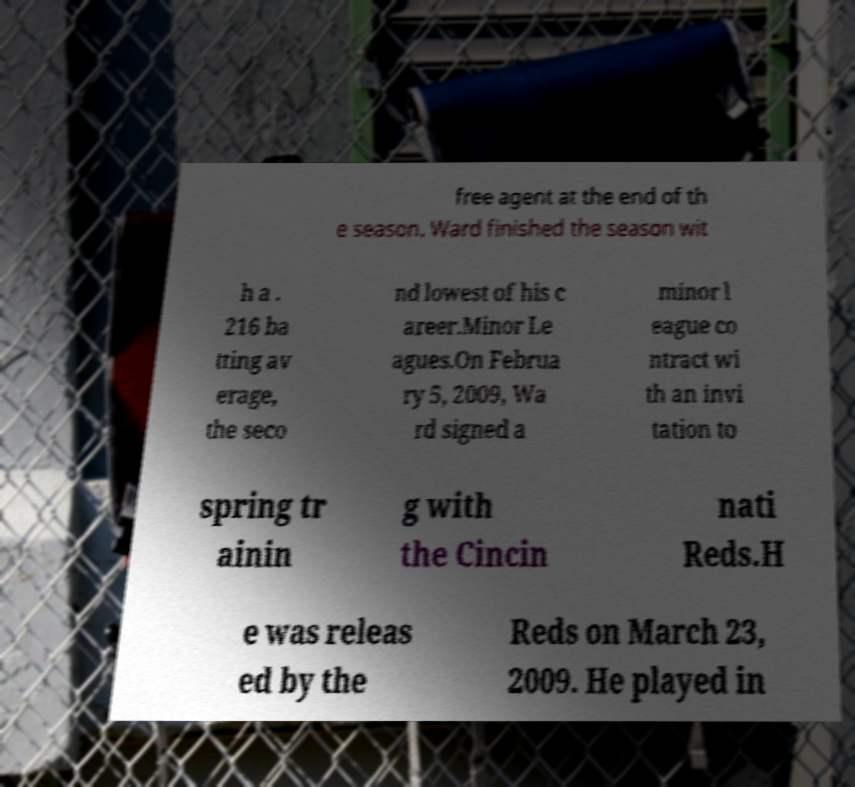I need the written content from this picture converted into text. Can you do that? free agent at the end of th e season. Ward finished the season wit h a . 216 ba tting av erage, the seco nd lowest of his c areer.Minor Le agues.On Februa ry 5, 2009, Wa rd signed a minor l eague co ntract wi th an invi tation to spring tr ainin g with the Cincin nati Reds.H e was releas ed by the Reds on March 23, 2009. He played in 